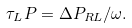<formula> <loc_0><loc_0><loc_500><loc_500>\tau _ { L } P = \Delta P _ { R L } / \omega .</formula> 